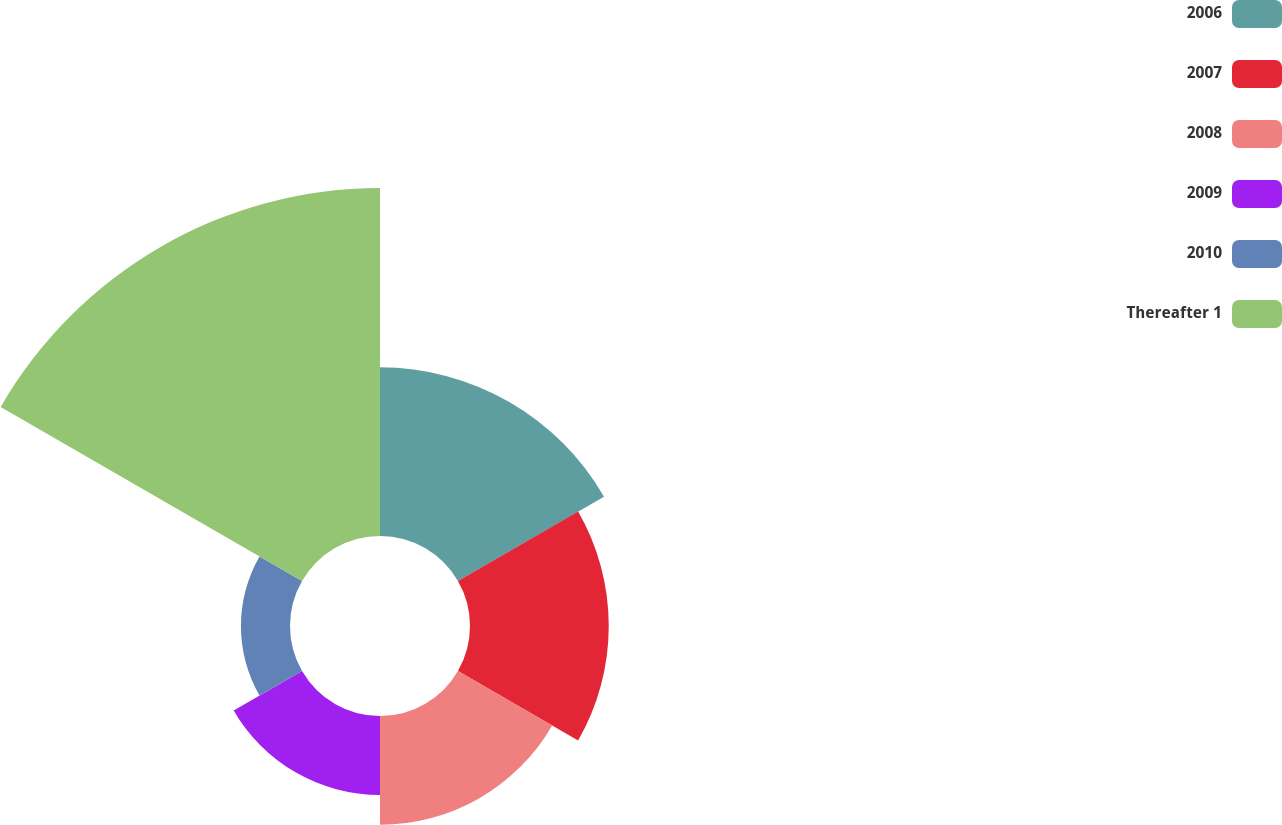Convert chart to OTSL. <chart><loc_0><loc_0><loc_500><loc_500><pie_chart><fcel>2006<fcel>2007<fcel>2008<fcel>2009<fcel>2010<fcel>Thereafter 1<nl><fcel>18.9%<fcel>15.55%<fcel>12.2%<fcel>8.85%<fcel>5.5%<fcel>39.0%<nl></chart> 